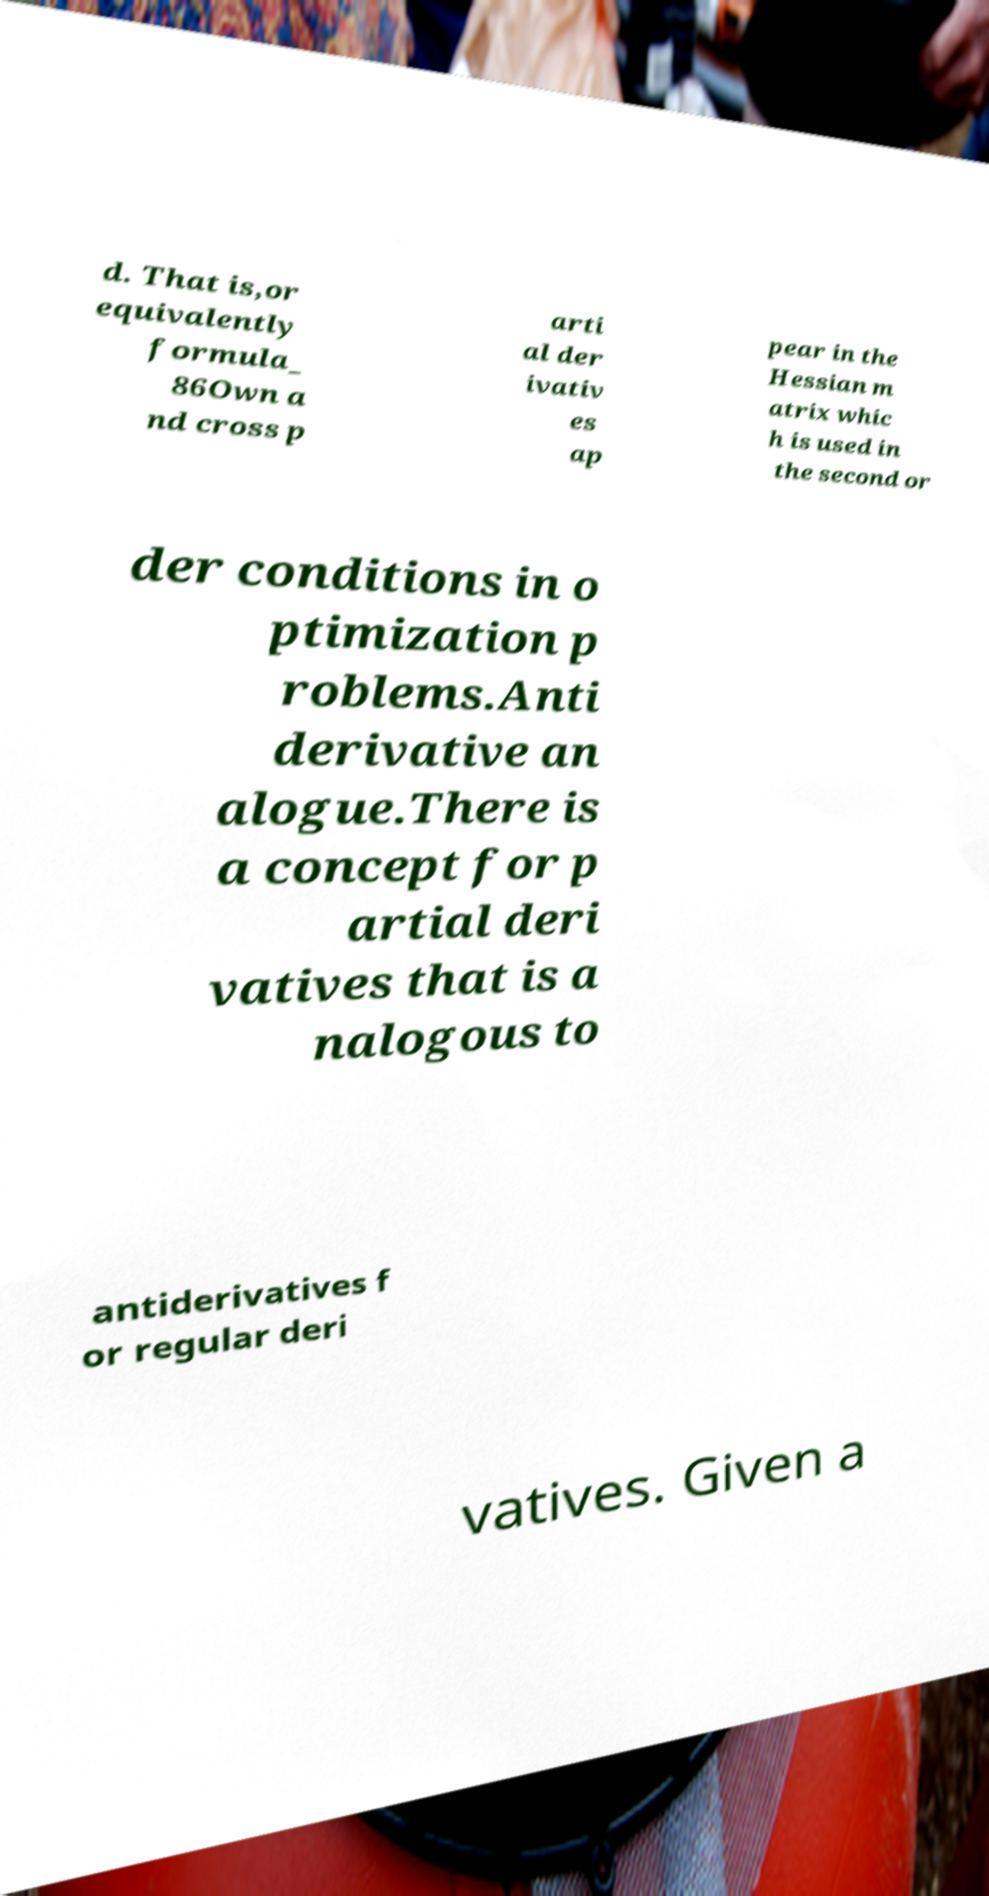Can you read and provide the text displayed in the image?This photo seems to have some interesting text. Can you extract and type it out for me? d. That is,or equivalently formula_ 86Own a nd cross p arti al der ivativ es ap pear in the Hessian m atrix whic h is used in the second or der conditions in o ptimization p roblems.Anti derivative an alogue.There is a concept for p artial deri vatives that is a nalogous to antiderivatives f or regular deri vatives. Given a 